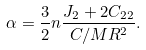Convert formula to latex. <formula><loc_0><loc_0><loc_500><loc_500>\alpha = \frac { 3 } { 2 } n \frac { J _ { 2 } + 2 C _ { 2 2 } } { C / M R ^ { 2 } } .</formula> 